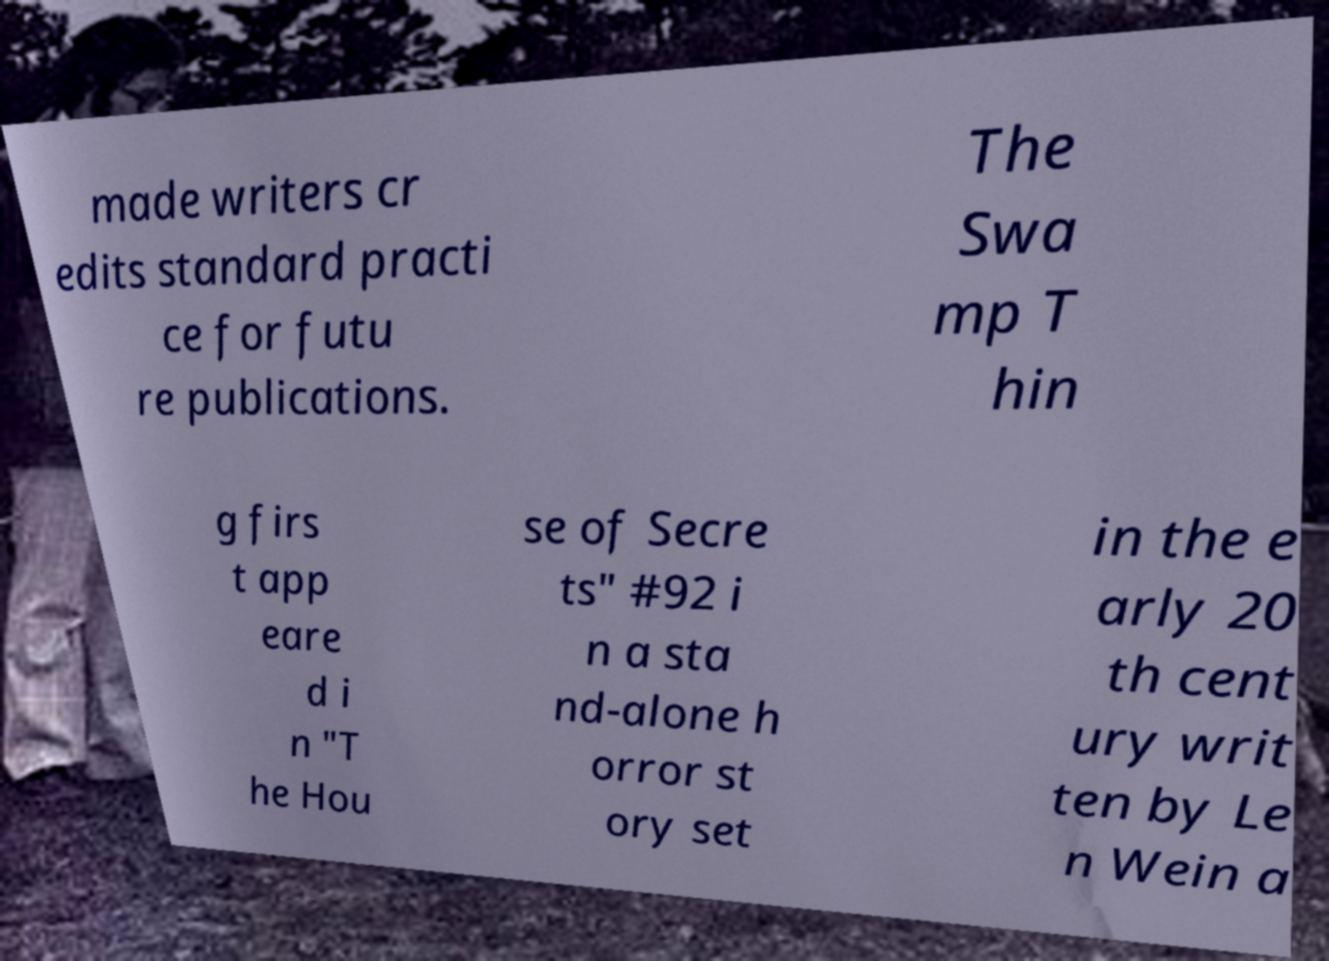Please read and relay the text visible in this image. What does it say? made writers cr edits standard practi ce for futu re publications. The Swa mp T hin g firs t app eare d i n "T he Hou se of Secre ts" #92 i n a sta nd-alone h orror st ory set in the e arly 20 th cent ury writ ten by Le n Wein a 